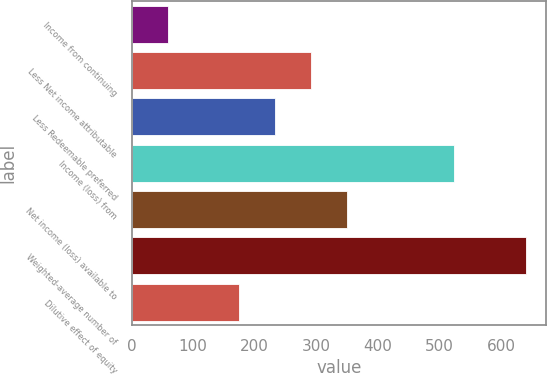<chart> <loc_0><loc_0><loc_500><loc_500><bar_chart><fcel>Income from continuing<fcel>Less Net income attributable<fcel>Less Redeemable preferred<fcel>Income (loss) from<fcel>Net income (loss) available to<fcel>Weighted-average number of<fcel>Dilutive effect of equity<nl><fcel>58.49<fcel>291.41<fcel>233.18<fcel>524.33<fcel>349.64<fcel>640.79<fcel>174.95<nl></chart> 